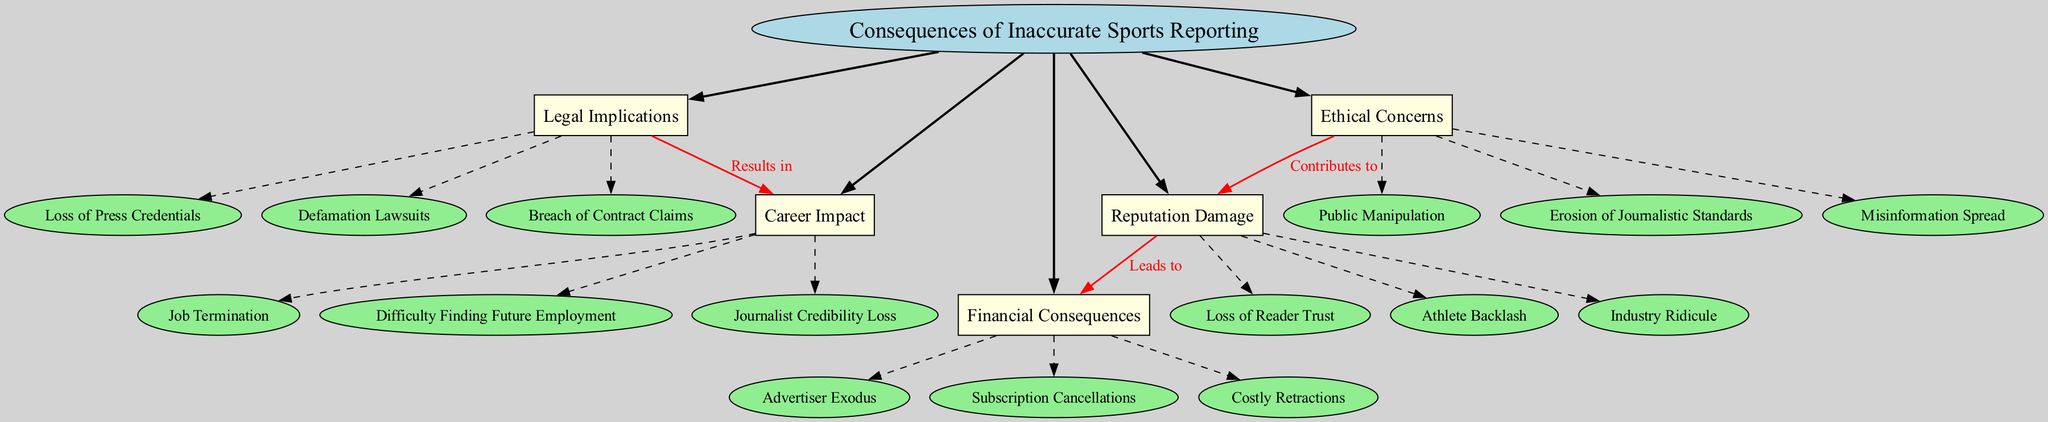What are the main branches in the diagram? The diagram displays five main branches: Legal Implications, Reputation Damage, Financial Consequences, Career Impact, and Ethical Concerns. Each main branch represents a category associated with the central topic.
Answer: Legal Implications, Reputation Damage, Financial Consequences, Career Impact, Ethical Concerns How many sub-branches are under Financial Consequences? Under Financial Consequences, there are three sub-branches listed: Advertiser Exodus, Subscription Cancellations, and Costly Retractions. This is simply counted as seen in the diagram.
Answer: 3 What connection leads from Ethical Concerns to Reputation Damage? The diagram indicates that Ethical Concerns contributes to Reputation Damage, as shown by the labeled connection in red. This describes the relationship in the context of the consequences of inaccurate sports reporting.
Answer: Contributes to Which main branch results in Career Impact? The Legal Implications branch is connected to Career Impact, indicating that this type of inaccurate reporting leads to consequences affecting career prospects within the industry.
Answer: Legal Implications What is one potential consequence listed under Career Impact? One potential consequence listed under Career Impact is Job Termination. This is specifically stated as a sub-branch under this main branch.
Answer: Job Termination What is the relationship between Reputation Damage and Financial Consequences? Reputation Damage leads to Financial Consequences, as shown in the diagram with a labeled red edge between the two branches, indicating a directional influence in the context of sports reporting consequences.
Answer: Leads to How does misinformation spread impact the diagram? Misinformation Spread is listed as a sub-branch under Ethical Concerns, contributing to broader issues like Reputation Damage. This indicates that this concern is part of the interrelations within the overall consequences depicted in the mind map.
Answer: Ethical Concerns What is the primary subject of the diagram? The primary subject is the "Consequences of Inaccurate Sports Reporting," which is stated in the central node at the top of the diagram. This serves as the foundation for all subsequent branches and sub-branches.
Answer: Consequences of Inaccurate Sports Reporting 